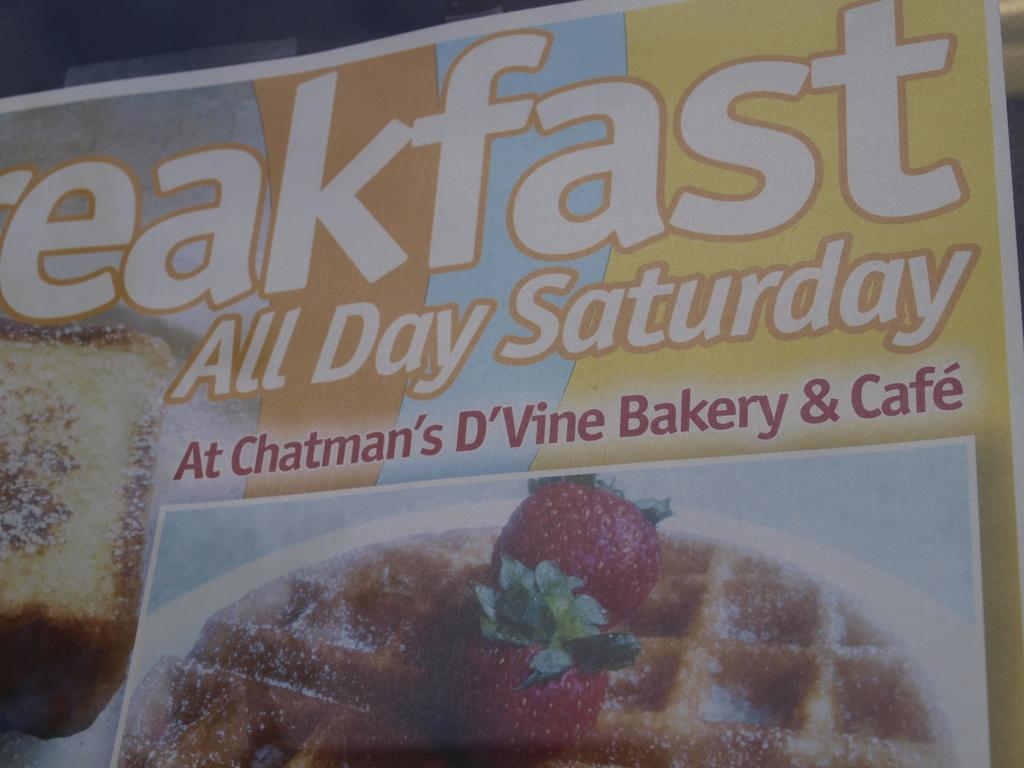What is the main object in the image? There is a board or a poster in the image. What colors are present on the board or poster? The board or poster has brown, blue, and yellow colors. Is there any text on the board or poster? Yes, there is text written on the board or poster. What type of image is at the bottom of the board or poster? There is a poster of a food item at the bottom of the board or poster. What type of silver vessel is depicted on the board or poster? There is no silver vessel present on the board or poster; it only features brown, blue, and yellow colors, text, and a food item poster at the bottom. 